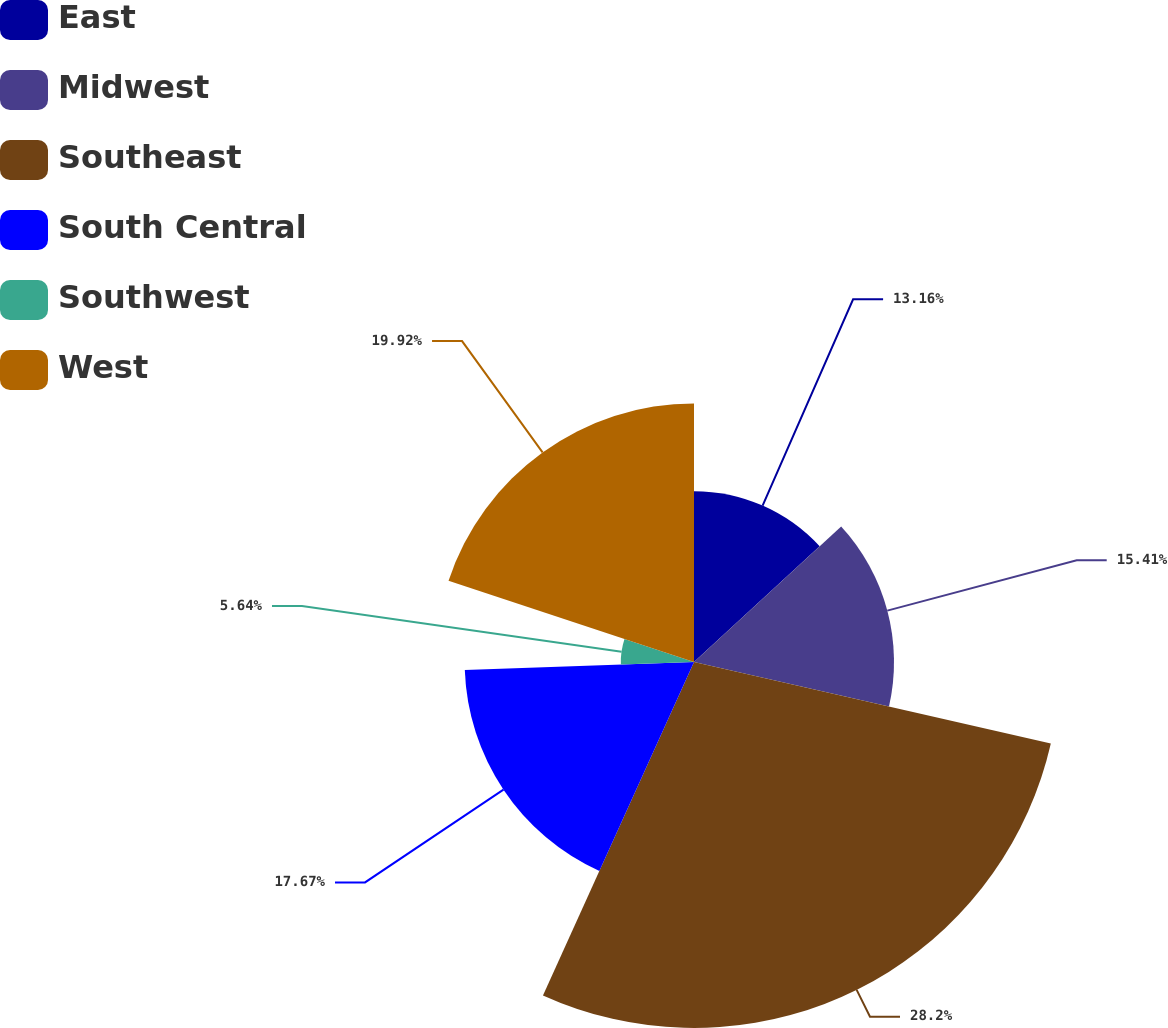Convert chart. <chart><loc_0><loc_0><loc_500><loc_500><pie_chart><fcel>East<fcel>Midwest<fcel>Southeast<fcel>South Central<fcel>Southwest<fcel>West<nl><fcel>13.16%<fcel>15.41%<fcel>28.2%<fcel>17.67%<fcel>5.64%<fcel>19.92%<nl></chart> 